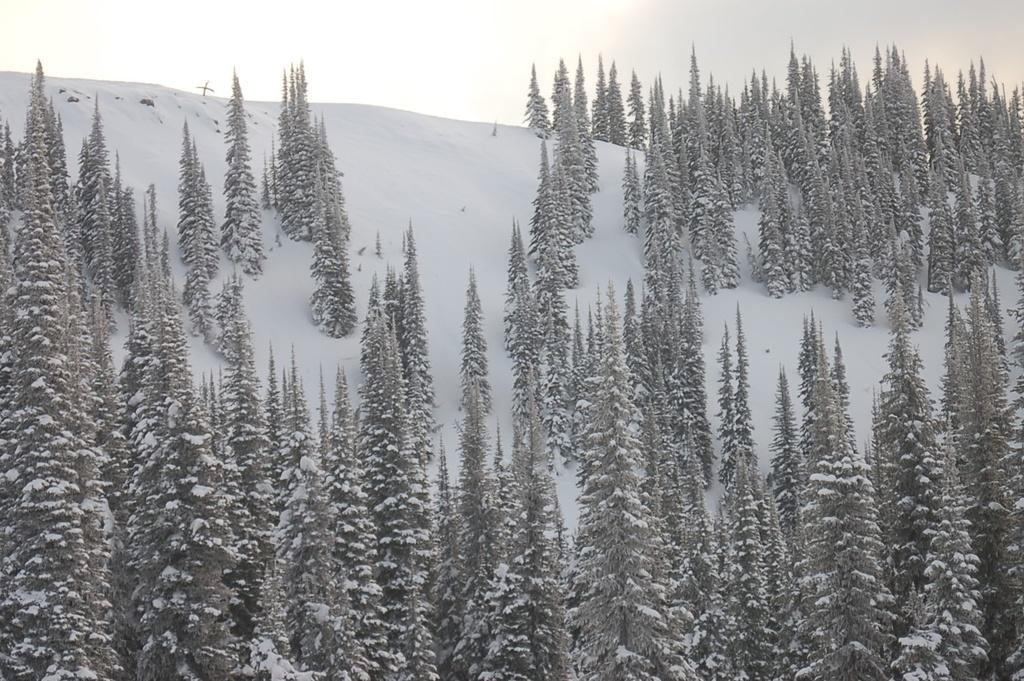What is the main feature of the picture? There is a mountain in the picture. Are there any plants on the mountain? Yes, there are trees on the mountain. What is the weather like on the mountain? The mountain has snow on it, which suggests a cold or wintery climate. Can you see the sky in the picture? Yes, the sky is visible at the top of the mountain. What type of stick can be seen in the picture? There is no stick present in the image. Can you see any oranges on the trees in the picture? There are no oranges visible in the image; the trees are covered in snow. 